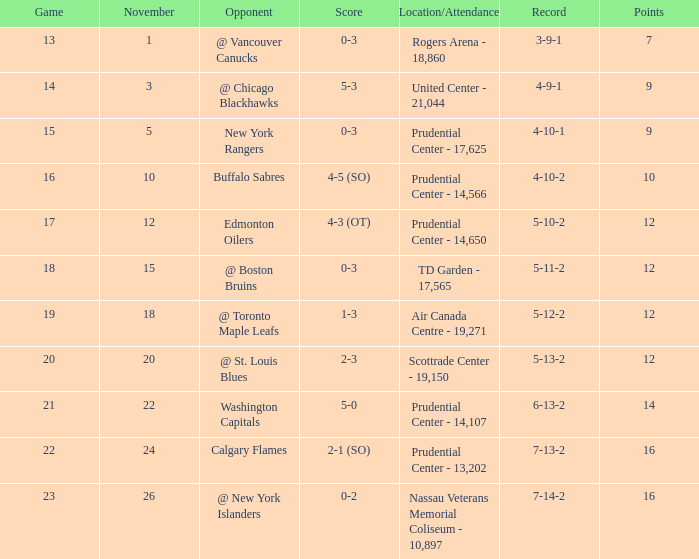What's the greatest number of points one can achieve? 16.0. Could you help me parse every detail presented in this table? {'header': ['Game', 'November', 'Opponent', 'Score', 'Location/Attendance', 'Record', 'Points'], 'rows': [['13', '1', '@ Vancouver Canucks', '0-3', 'Rogers Arena - 18,860', '3-9-1', '7'], ['14', '3', '@ Chicago Blackhawks', '5-3', 'United Center - 21,044', '4-9-1', '9'], ['15', '5', 'New York Rangers', '0-3', 'Prudential Center - 17,625', '4-10-1', '9'], ['16', '10', 'Buffalo Sabres', '4-5 (SO)', 'Prudential Center - 14,566', '4-10-2', '10'], ['17', '12', 'Edmonton Oilers', '4-3 (OT)', 'Prudential Center - 14,650', '5-10-2', '12'], ['18', '15', '@ Boston Bruins', '0-3', 'TD Garden - 17,565', '5-11-2', '12'], ['19', '18', '@ Toronto Maple Leafs', '1-3', 'Air Canada Centre - 19,271', '5-12-2', '12'], ['20', '20', '@ St. Louis Blues', '2-3', 'Scottrade Center - 19,150', '5-13-2', '12'], ['21', '22', 'Washington Capitals', '5-0', 'Prudential Center - 14,107', '6-13-2', '14'], ['22', '24', 'Calgary Flames', '2-1 (SO)', 'Prudential Center - 13,202', '7-13-2', '16'], ['23', '26', '@ New York Islanders', '0-2', 'Nassau Veterans Memorial Coliseum - 10,897', '7-14-2', '16']]} 